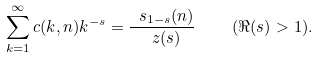<formula> <loc_0><loc_0><loc_500><loc_500>\sum ^ { \infty } _ { k = 1 } c ( k , n ) k ^ { - s } = \frac { \ s _ { 1 - s } ( n ) } { \ z ( s ) } \quad ( \Re ( s ) > 1 ) .</formula> 